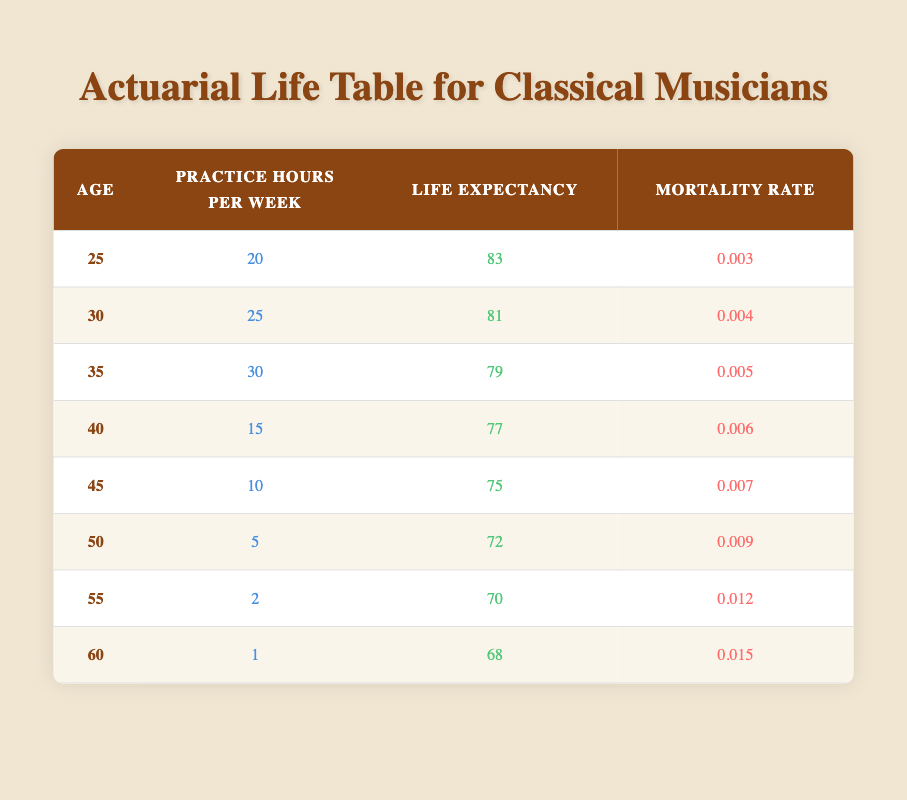What is the life expectancy of a 30-year-old musician who practices 25 hours per week? The table shows that the life expectancy for a 30-year-old musician practicing 25 hours per week is 81 years.
Answer: 81 How does the mortality rate change from age 25 to age 40? The mortality rate at age 25 is 0.003 and at age 40 it is 0.006. The change is 0.006 - 0.003 = 0.003.
Answer: 0.003 What is the average life expectancy of musicians aged 25 to 35? The life expectancies for ages 25, 30, and 35 are 83, 81, and 79 respectively. The sum is 83 + 81 + 79 = 243, and the average is 243 / 3 = 81.
Answer: 81 Is it true that a musician who practices more than 20 hours per week tends to have a higher life expectancy than a musician who practices less than that? Musicians practicing 20 hours or more (25 hours at 30 years and 20 hours at 25 years) have life expectancies of 81 and 83 respectively, while those practicing less (15 hours at 40 years) have 77. Therefore, this statement is true.
Answer: Yes What is the trend of life expectancy as practice hours per week decrease from ages 25 to 55? The life expectancies are 83 at age 25 (with 20 hours), 81 at age 30 (25 hours), 79 at age 35 (30 hours), 77 at age 40 (15 hours), 75 at age 45 (10 hours), 72 at age 50 (5 hours), and 70 at age 55 (2 hours). The trend shows a decrease in life expectancy as practice hours decrease.
Answer: Decrease 